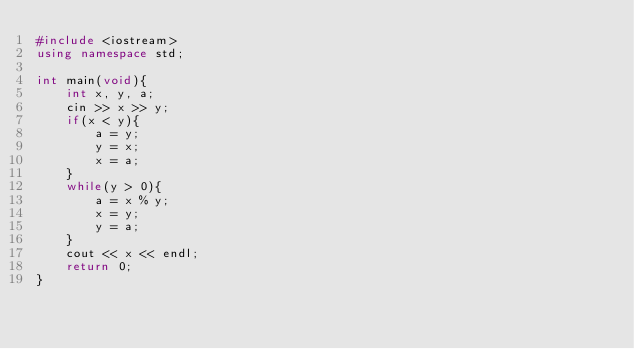Convert code to text. <code><loc_0><loc_0><loc_500><loc_500><_C++_>#include <iostream>
using namespace std;

int main(void){
    int x, y, a;
    cin >> x >> y;
    if(x < y){
        a = y;
        y = x;
        x = a;
    }
    while(y > 0){
        a = x % y;
        x = y;
        y = a;
    }
    cout << x << endl;
    return 0;
}</code> 